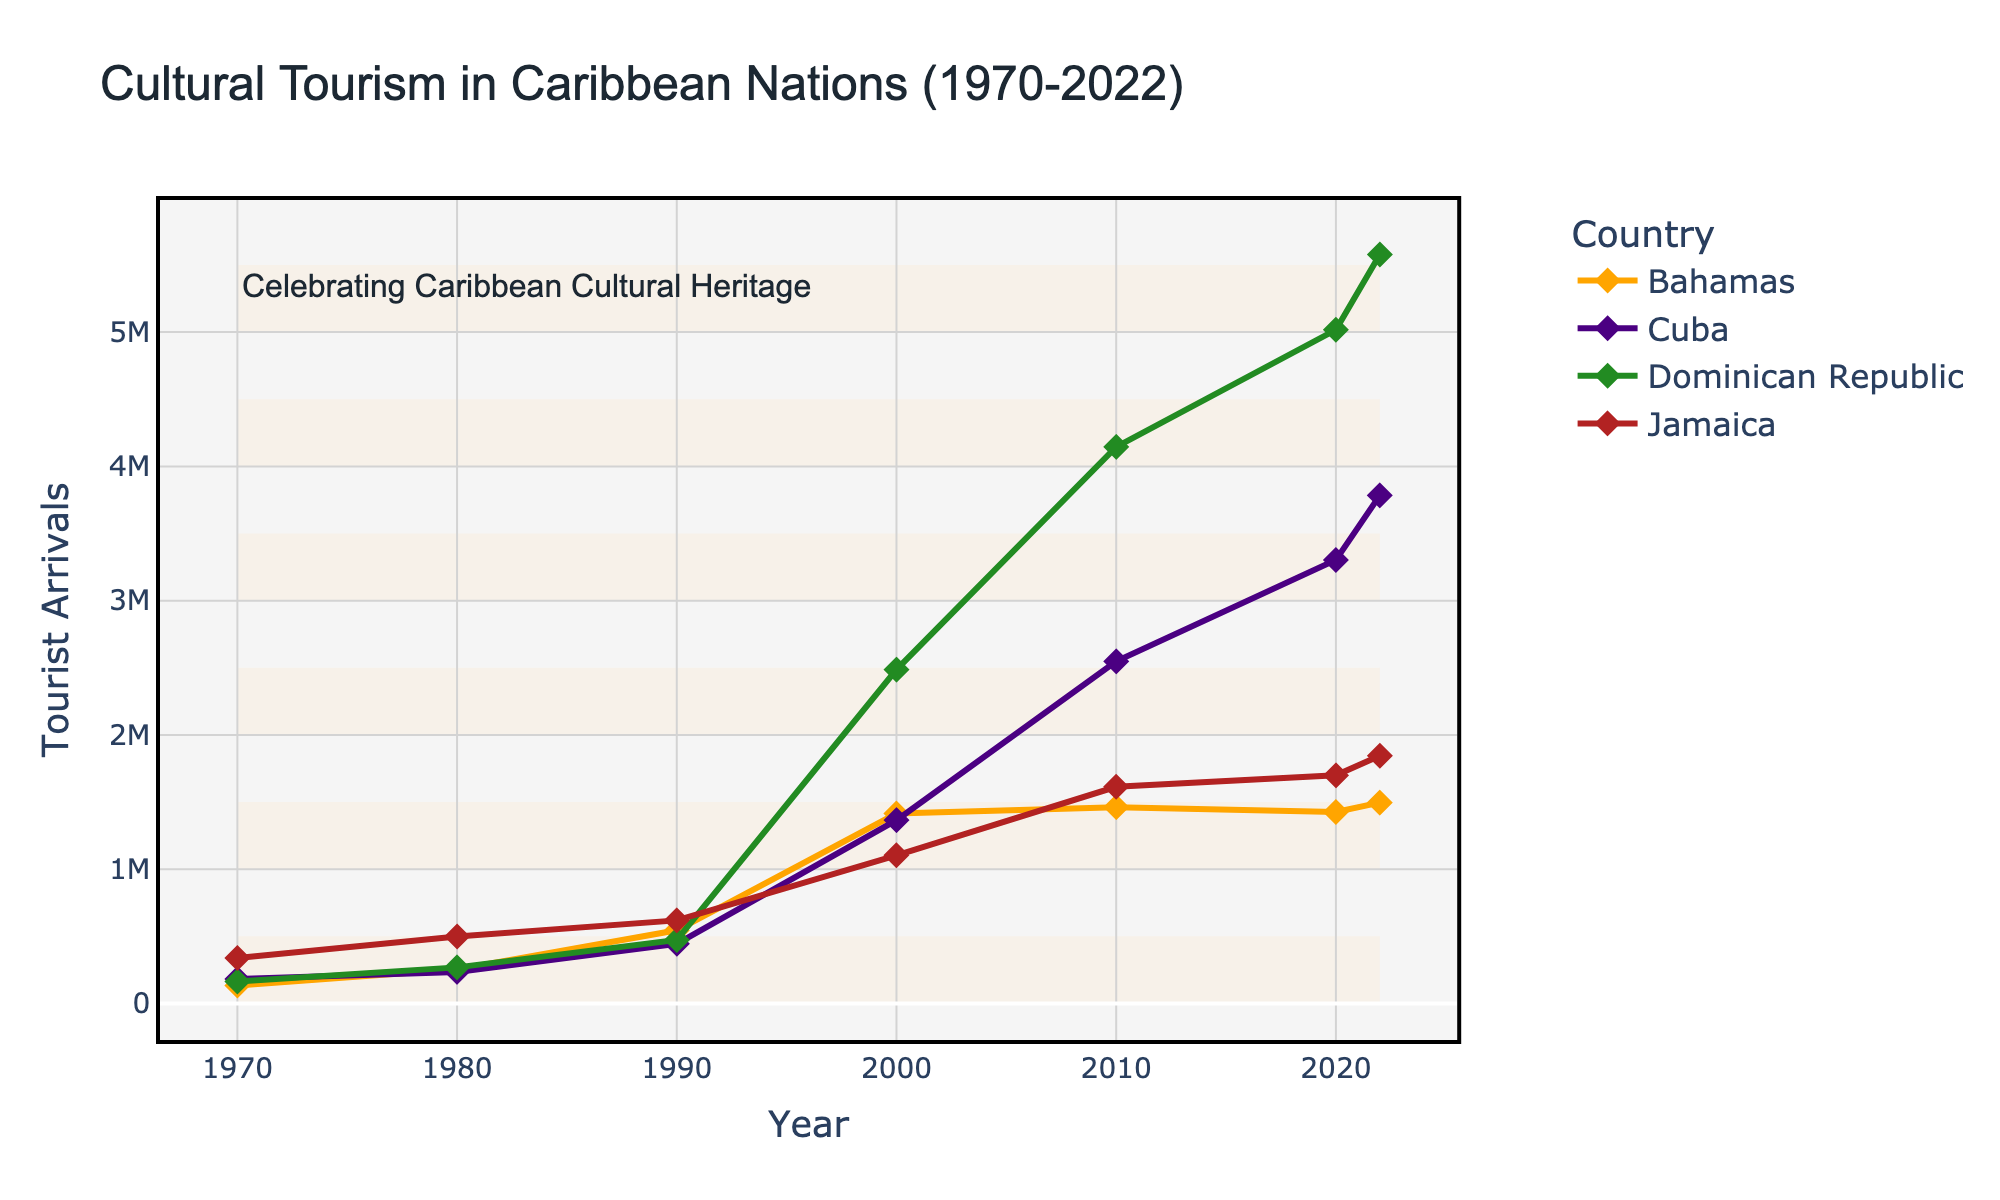What is the title of the plot? The title of the plot is placed at the top and clearly reads "Cultural Tourism in Caribbean Nations (1970-2022)."
Answer: Cultural Tourism in Caribbean Nations (1970-2022) What are the x-axis and y-axis representing in the figure? The x-axis represents the "Year," and the y-axis represents "Tourist Arrivals." These are indicated by the labels provided on each axis.
Answer: The x-axis represents the "Year," and the y-axis represents "Tourist Arrivals." Which country had the highest tourist arrivals in 2022? By following the 2022 mark on the x-axis and checking the peaks of each line, the Dominican Republic exhibits the highest value on the y-axis for tourist arrivals.
Answer: Dominican Republic How did tourist arrivals in Jamaica change from 1970 to 2022? By tracking the line for Jamaica, we can see the trend starts at 339,000 in 1970 and gradually increases to 1,845,000 in 2022. This shows a general trend of growth over the years.
Answer: Increased Which country showed a sudden increase in tourist arrivals between 2010 and 2020? By analyzing the slant of the lines between 2010 and 2020, the Dominican Republic shows a steep incline, indicating a notable increase in tourist arrivals during this period.
Answer: Dominican Republic What is the combined total of tourist arrivals for Jamaica and Cuba in 2022? In 2022, Jamaica had 1,845,000 and Cuba had 3,784,000 tourist arrivals. Adding these numbers together gives a total of 5,629,000.
Answer: 5,629,000 How does the trend in tourist arrivals in the Bahamas from 1970 to 2022 compare with Cuba? Looking at the plots for both countries, the Bahamas shows a more consistent number of arrivals over the years, whereas Cuba shows a more pronounced increase, especially after 1980.
Answer: Consistent vs. Pronounced increase Which country had consistent growth in tourist arrivals without any dips from 1970 to 2022? By analyzing the lines for all countries, the Dominican Republic consistently shows an upward trend without any noticeable dips from 1970 to 2022.
Answer: Dominican Republic 